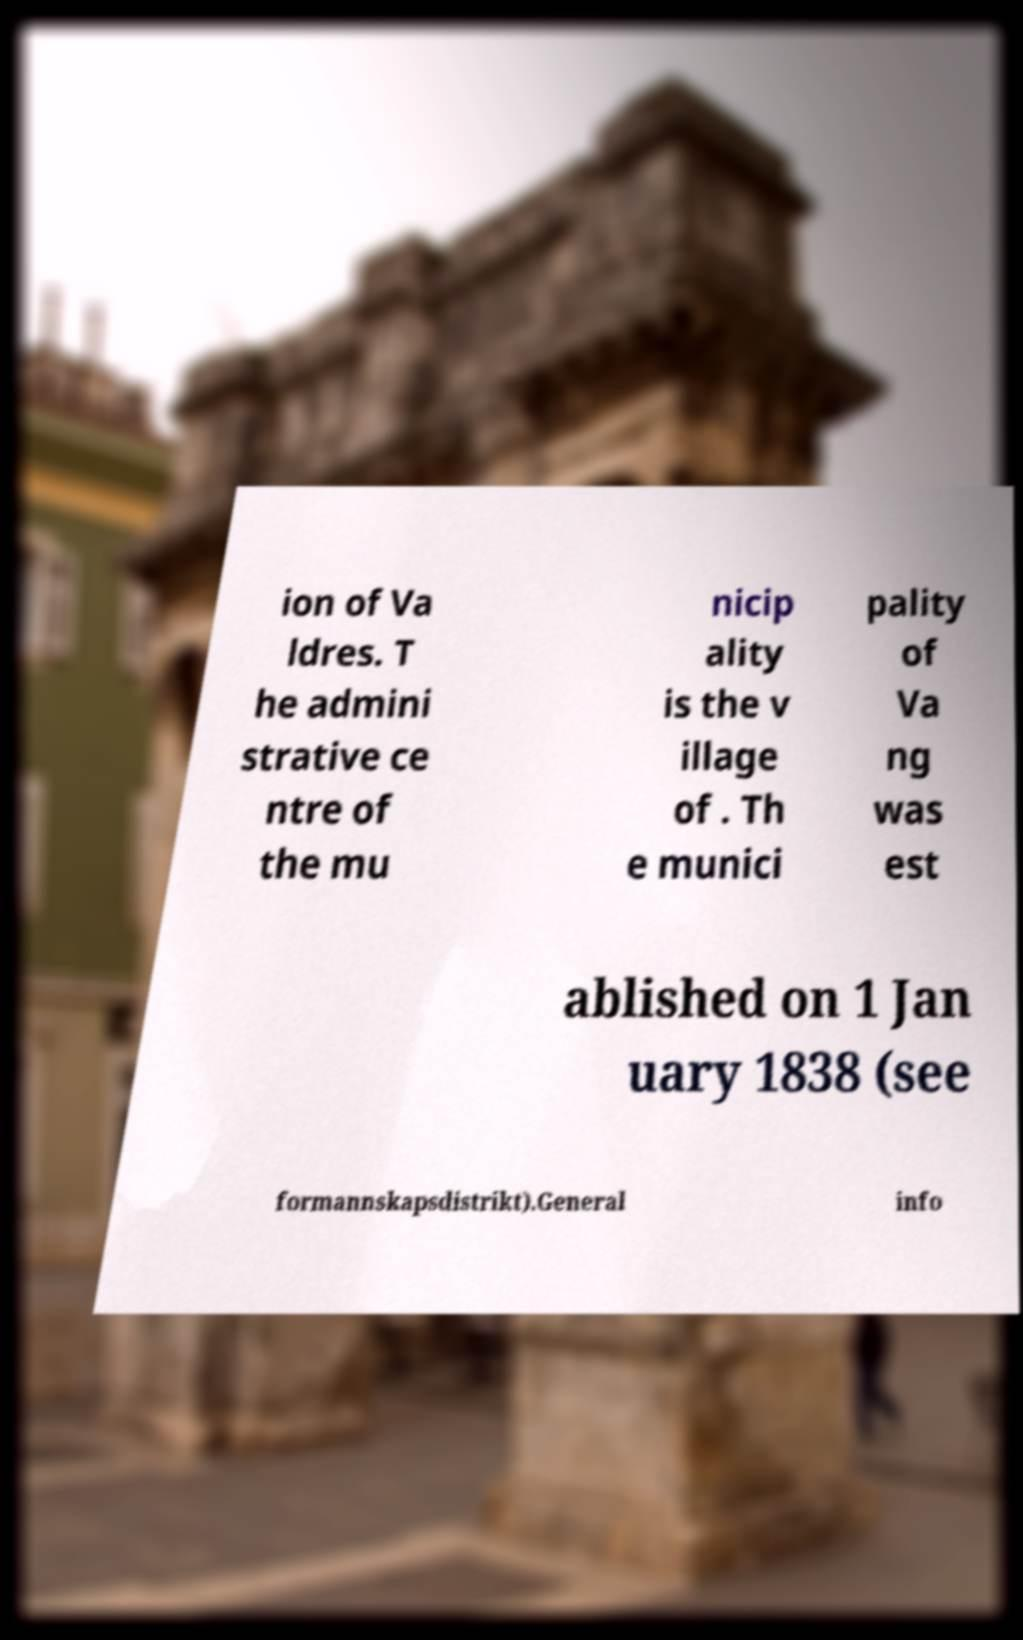There's text embedded in this image that I need extracted. Can you transcribe it verbatim? ion of Va ldres. T he admini strative ce ntre of the mu nicip ality is the v illage of . Th e munici pality of Va ng was est ablished on 1 Jan uary 1838 (see formannskapsdistrikt).General info 